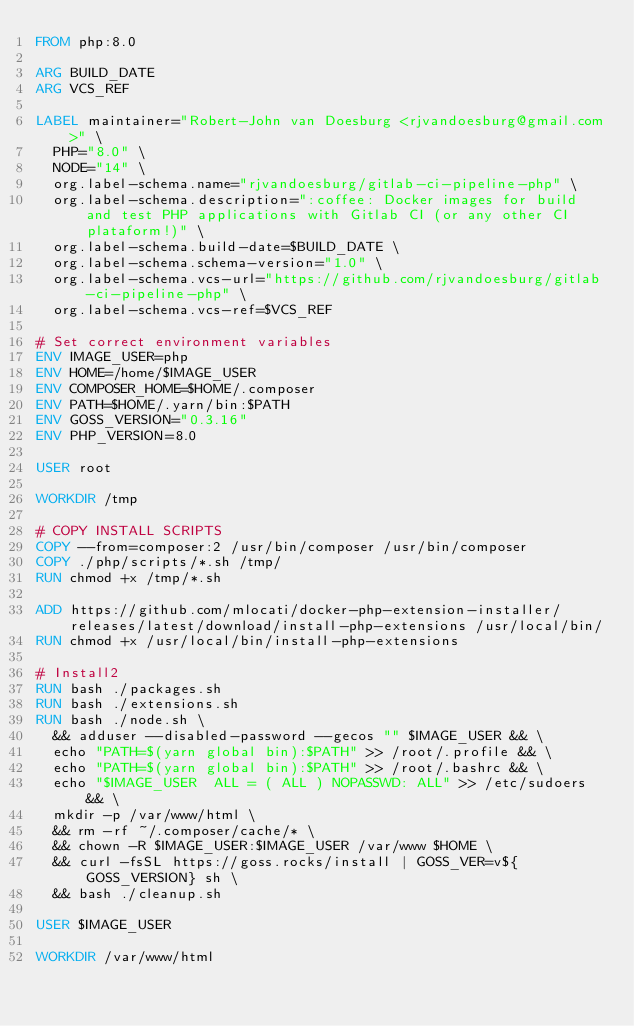<code> <loc_0><loc_0><loc_500><loc_500><_Dockerfile_>FROM php:8.0

ARG BUILD_DATE
ARG VCS_REF

LABEL maintainer="Robert-John van Doesburg <rjvandoesburg@gmail.com>" \
  PHP="8.0" \
  NODE="14" \
  org.label-schema.name="rjvandoesburg/gitlab-ci-pipeline-php" \
  org.label-schema.description=":coffee: Docker images for build and test PHP applications with Gitlab CI (or any other CI plataform!)" \
  org.label-schema.build-date=$BUILD_DATE \
  org.label-schema.schema-version="1.0" \
  org.label-schema.vcs-url="https://github.com/rjvandoesburg/gitlab-ci-pipeline-php" \
  org.label-schema.vcs-ref=$VCS_REF

# Set correct environment variables
ENV IMAGE_USER=php
ENV HOME=/home/$IMAGE_USER
ENV COMPOSER_HOME=$HOME/.composer
ENV PATH=$HOME/.yarn/bin:$PATH
ENV GOSS_VERSION="0.3.16"
ENV PHP_VERSION=8.0

USER root

WORKDIR /tmp

# COPY INSTALL SCRIPTS
COPY --from=composer:2 /usr/bin/composer /usr/bin/composer
COPY ./php/scripts/*.sh /tmp/
RUN chmod +x /tmp/*.sh

ADD https://github.com/mlocati/docker-php-extension-installer/releases/latest/download/install-php-extensions /usr/local/bin/
RUN chmod +x /usr/local/bin/install-php-extensions

# Install2
RUN bash ./packages.sh
RUN bash ./extensions.sh
RUN bash ./node.sh \
  && adduser --disabled-password --gecos "" $IMAGE_USER && \
  echo "PATH=$(yarn global bin):$PATH" >> /root/.profile && \
  echo "PATH=$(yarn global bin):$PATH" >> /root/.bashrc && \
  echo "$IMAGE_USER  ALL = ( ALL ) NOPASSWD: ALL" >> /etc/sudoers && \
  mkdir -p /var/www/html \
  && rm -rf ~/.composer/cache/* \
  && chown -R $IMAGE_USER:$IMAGE_USER /var/www $HOME \
  && curl -fsSL https://goss.rocks/install | GOSS_VER=v${GOSS_VERSION} sh \
  && bash ./cleanup.sh

USER $IMAGE_USER

WORKDIR /var/www/html
</code> 